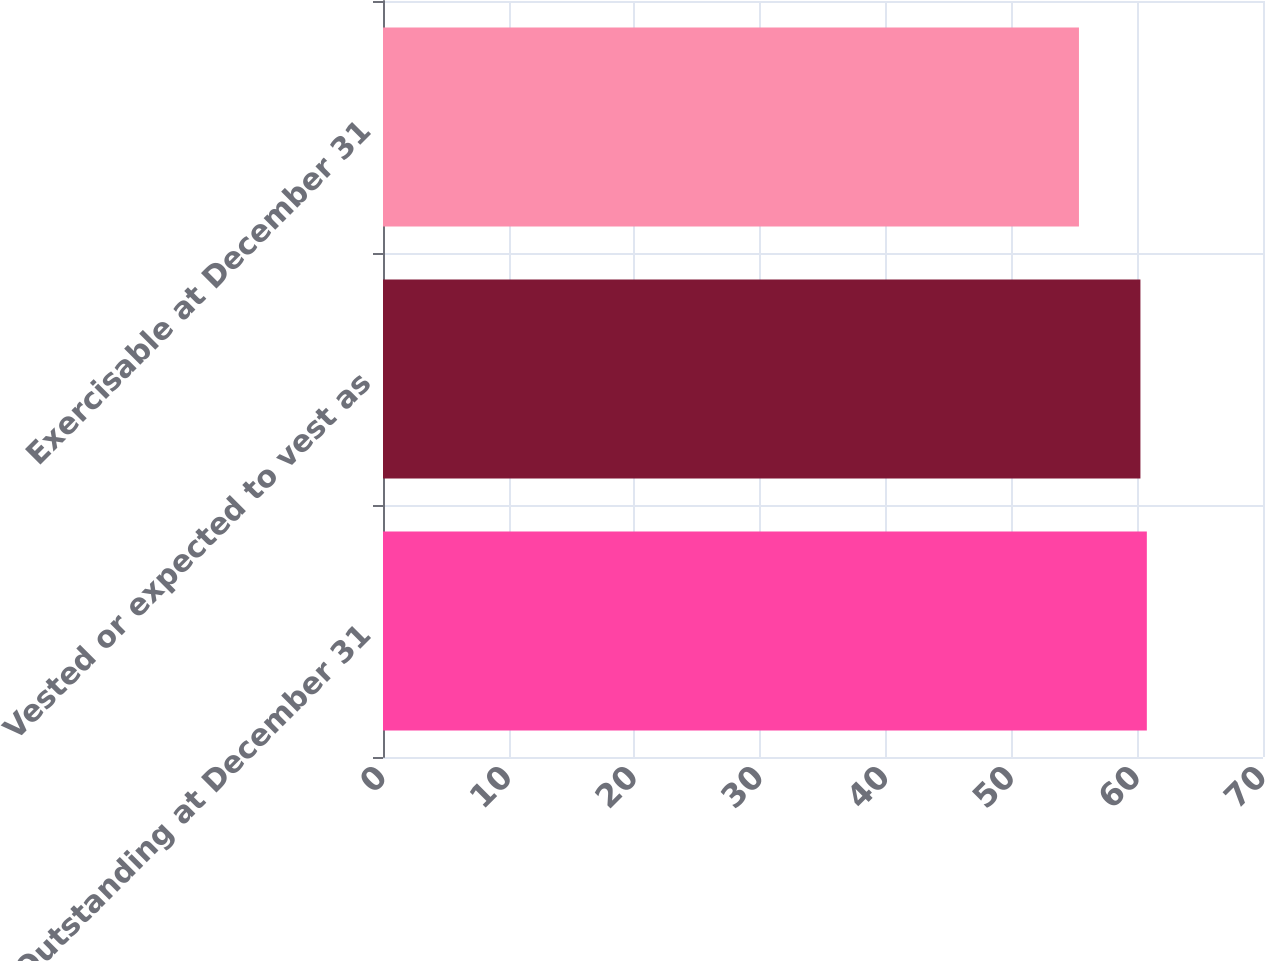Convert chart. <chart><loc_0><loc_0><loc_500><loc_500><bar_chart><fcel>Outstanding at December 31<fcel>Vested or expected to vest as<fcel>Exercisable at December 31<nl><fcel>60.76<fcel>60.25<fcel>55.36<nl></chart> 